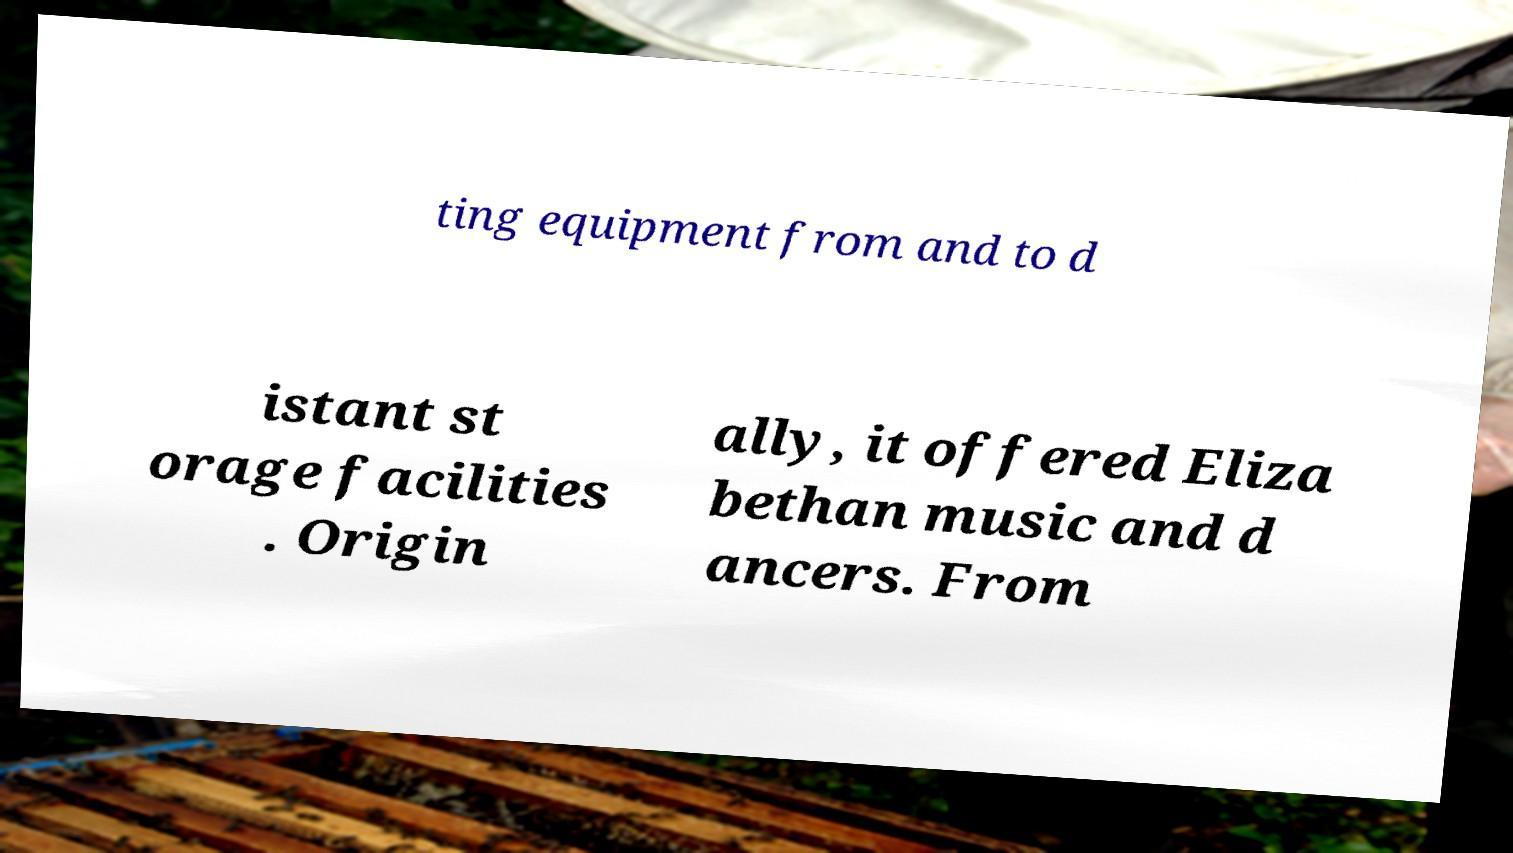I need the written content from this picture converted into text. Can you do that? ting equipment from and to d istant st orage facilities . Origin ally, it offered Eliza bethan music and d ancers. From 